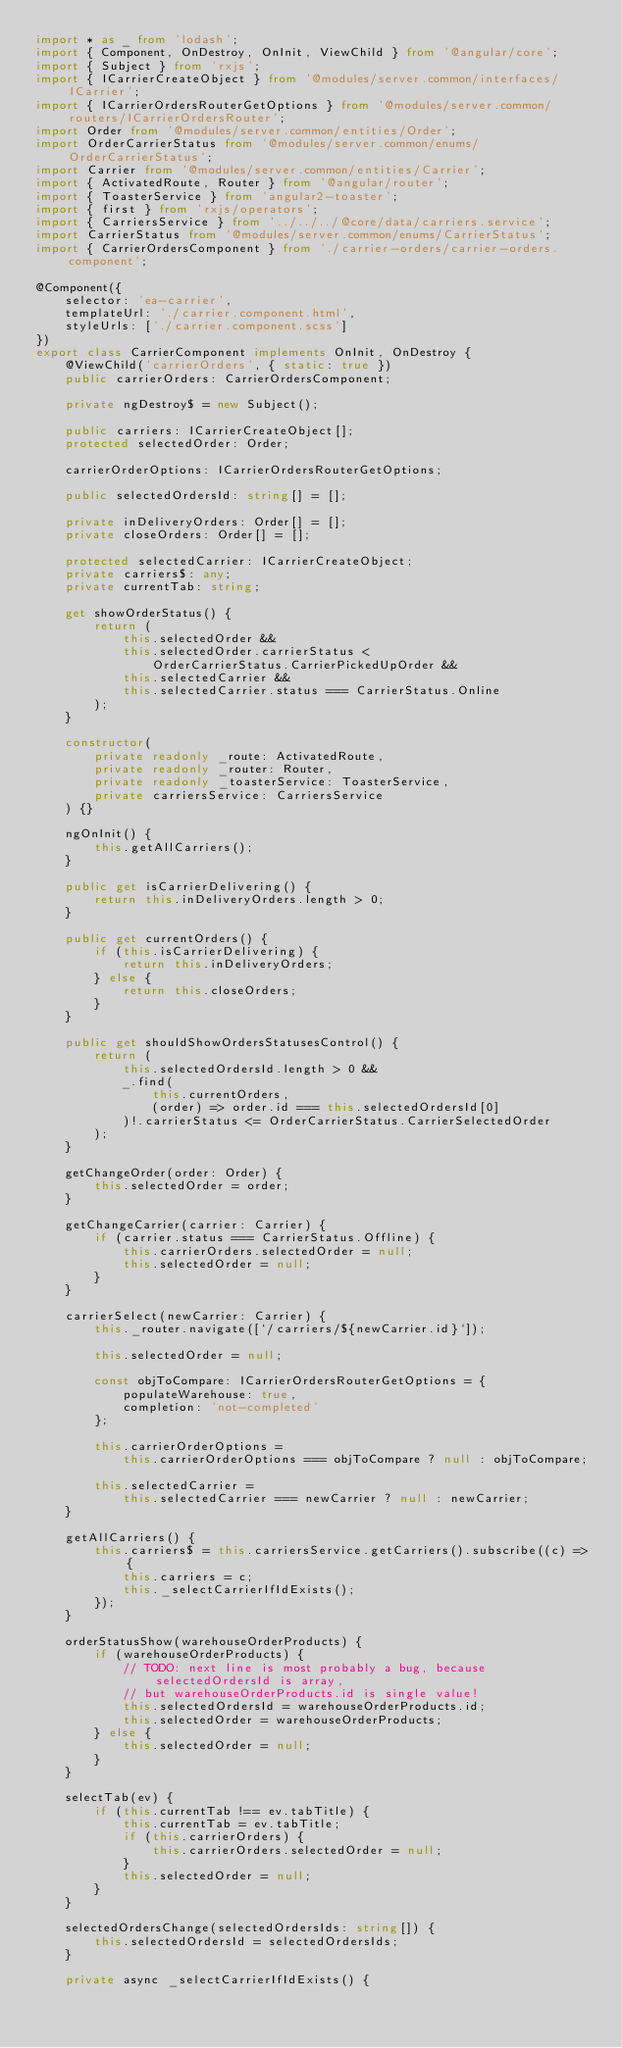<code> <loc_0><loc_0><loc_500><loc_500><_TypeScript_>import * as _ from 'lodash';
import { Component, OnDestroy, OnInit, ViewChild } from '@angular/core';
import { Subject } from 'rxjs';
import { ICarrierCreateObject } from '@modules/server.common/interfaces/ICarrier';
import { ICarrierOrdersRouterGetOptions } from '@modules/server.common/routers/ICarrierOrdersRouter';
import Order from '@modules/server.common/entities/Order';
import OrderCarrierStatus from '@modules/server.common/enums/OrderCarrierStatus';
import Carrier from '@modules/server.common/entities/Carrier';
import { ActivatedRoute, Router } from '@angular/router';
import { ToasterService } from 'angular2-toaster';
import { first } from 'rxjs/operators';
import { CarriersService } from '../../../@core/data/carriers.service';
import CarrierStatus from '@modules/server.common/enums/CarrierStatus';
import { CarrierOrdersComponent } from './carrier-orders/carrier-orders.component';

@Component({
	selector: 'ea-carrier',
	templateUrl: './carrier.component.html',
	styleUrls: ['./carrier.component.scss']
})
export class CarrierComponent implements OnInit, OnDestroy {
	@ViewChild('carrierOrders', { static: true })
	public carrierOrders: CarrierOrdersComponent;

	private ngDestroy$ = new Subject();

	public carriers: ICarrierCreateObject[];
	protected selectedOrder: Order;

	carrierOrderOptions: ICarrierOrdersRouterGetOptions;

	public selectedOrdersId: string[] = [];

	private inDeliveryOrders: Order[] = [];
	private closeOrders: Order[] = [];

	protected selectedCarrier: ICarrierCreateObject;
	private carriers$: any;
	private currentTab: string;

	get showOrderStatus() {
		return (
			this.selectedOrder &&
			this.selectedOrder.carrierStatus <
				OrderCarrierStatus.CarrierPickedUpOrder &&
			this.selectedCarrier &&
			this.selectedCarrier.status === CarrierStatus.Online
		);
	}

	constructor(
		private readonly _route: ActivatedRoute,
		private readonly _router: Router,
		private readonly _toasterService: ToasterService,
		private carriersService: CarriersService
	) {}

	ngOnInit() {
		this.getAllCarriers();
	}

	public get isCarrierDelivering() {
		return this.inDeliveryOrders.length > 0;
	}

	public get currentOrders() {
		if (this.isCarrierDelivering) {
			return this.inDeliveryOrders;
		} else {
			return this.closeOrders;
		}
	}

	public get shouldShowOrdersStatusesControl() {
		return (
			this.selectedOrdersId.length > 0 &&
			_.find(
				this.currentOrders,
				(order) => order.id === this.selectedOrdersId[0]
			)!.carrierStatus <= OrderCarrierStatus.CarrierSelectedOrder
		);
	}

	getChangeOrder(order: Order) {
		this.selectedOrder = order;
	}

	getChangeCarrier(carrier: Carrier) {
		if (carrier.status === CarrierStatus.Offline) {
			this.carrierOrders.selectedOrder = null;
			this.selectedOrder = null;
		}
	}

	carrierSelect(newCarrier: Carrier) {
		this._router.navigate([`/carriers/${newCarrier.id}`]);

		this.selectedOrder = null;

		const objToCompare: ICarrierOrdersRouterGetOptions = {
			populateWarehouse: true,
			completion: 'not-completed'
		};

		this.carrierOrderOptions =
			this.carrierOrderOptions === objToCompare ? null : objToCompare;

		this.selectedCarrier =
			this.selectedCarrier === newCarrier ? null : newCarrier;
	}

	getAllCarriers() {
		this.carriers$ = this.carriersService.getCarriers().subscribe((c) => {
			this.carriers = c;
			this._selectCarrierIfIdExists();
		});
	}

	orderStatusShow(warehouseOrderProducts) {
		if (warehouseOrderProducts) {
			// TODO: next line is most probably a bug, because selectedOrdersId is array,
			// but warehouseOrderProducts.id is single value!
			this.selectedOrdersId = warehouseOrderProducts.id;
			this.selectedOrder = warehouseOrderProducts;
		} else {
			this.selectedOrder = null;
		}
	}

	selectTab(ev) {
		if (this.currentTab !== ev.tabTitle) {
			this.currentTab = ev.tabTitle;
			if (this.carrierOrders) {
				this.carrierOrders.selectedOrder = null;
			}
			this.selectedOrder = null;
		}
	}

	selectedOrdersChange(selectedOrdersIds: string[]) {
		this.selectedOrdersId = selectedOrdersIds;
	}

	private async _selectCarrierIfIdExists() {</code> 